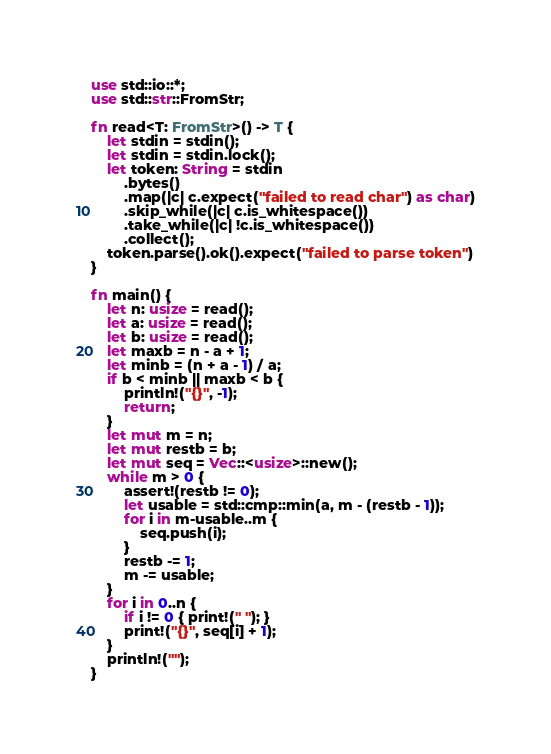<code> <loc_0><loc_0><loc_500><loc_500><_Rust_>use std::io::*;
use std::str::FromStr;

fn read<T: FromStr>() -> T {
    let stdin = stdin();
    let stdin = stdin.lock();
    let token: String = stdin
        .bytes()
        .map(|c| c.expect("failed to read char") as char)
        .skip_while(|c| c.is_whitespace())
        .take_while(|c| !c.is_whitespace())
        .collect();
    token.parse().ok().expect("failed to parse token")
}

fn main() {
    let n: usize = read();
    let a: usize = read();
    let b: usize = read();
    let maxb = n - a + 1;
    let minb = (n + a - 1) / a;
    if b < minb || maxb < b {
        println!("{}", -1);
        return;
    }
    let mut m = n;
    let mut restb = b;
    let mut seq = Vec::<usize>::new();
    while m > 0 {
        assert!(restb != 0);
        let usable = std::cmp::min(a, m - (restb - 1));
        for i in m-usable..m {
            seq.push(i);
        }
        restb -= 1;
        m -= usable;
    }
    for i in 0..n {
        if i != 0 { print!(" "); }
        print!("{}", seq[i] + 1);
    }
    println!("");
}</code> 